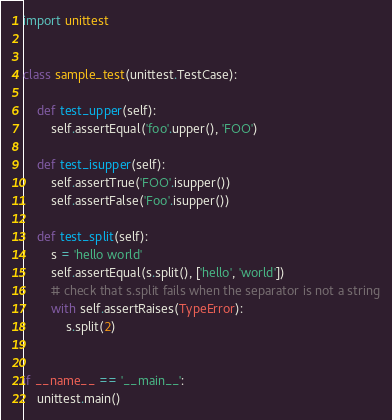Convert code to text. <code><loc_0><loc_0><loc_500><loc_500><_Python_>import unittest


class sample_test(unittest.TestCase):

    def test_upper(self):
        self.assertEqual('foo'.upper(), 'FOO')

    def test_isupper(self):
        self.assertTrue('FOO'.isupper())
        self.assertFalse('Foo'.isupper())

    def test_split(self):
        s = 'hello world'
        self.assertEqual(s.split(), ['hello', 'world'])
        # check that s.split fails when the separator is not a string
        with self.assertRaises(TypeError):
            s.split(2)


if __name__ == '__main__':
    unittest.main()
</code> 